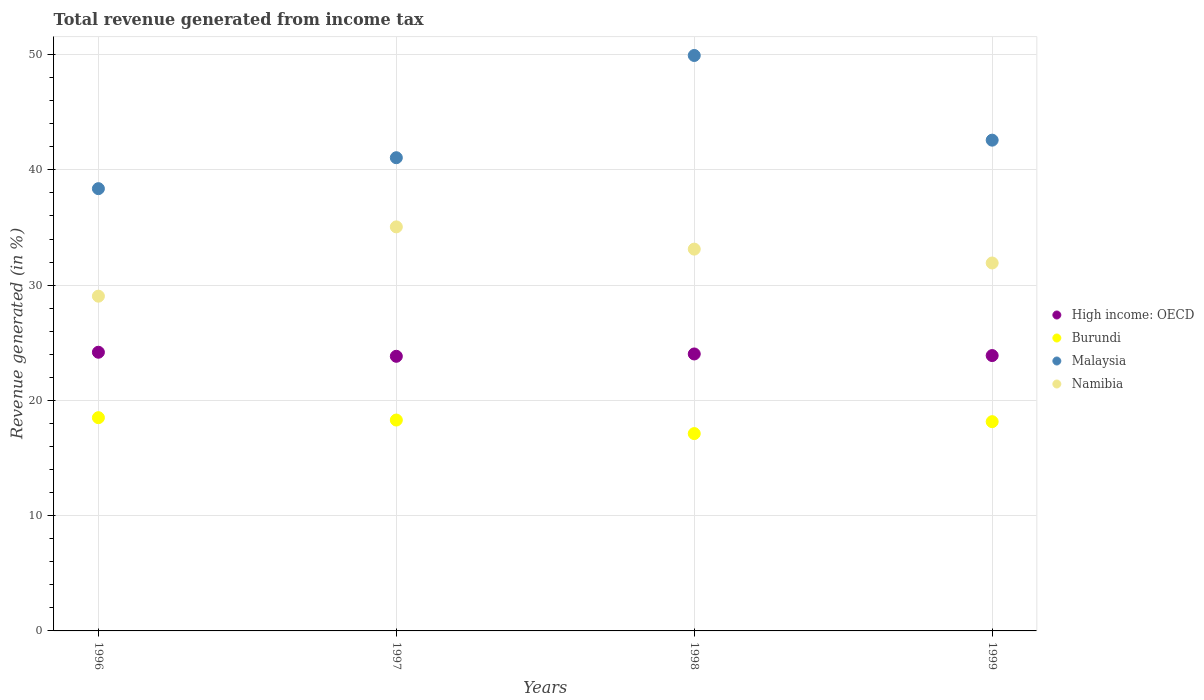Is the number of dotlines equal to the number of legend labels?
Give a very brief answer. Yes. What is the total revenue generated in Malaysia in 1997?
Keep it short and to the point. 41.06. Across all years, what is the maximum total revenue generated in High income: OECD?
Ensure brevity in your answer.  24.18. Across all years, what is the minimum total revenue generated in Malaysia?
Your answer should be very brief. 38.37. In which year was the total revenue generated in Burundi maximum?
Keep it short and to the point. 1996. What is the total total revenue generated in High income: OECD in the graph?
Keep it short and to the point. 95.92. What is the difference between the total revenue generated in Malaysia in 1996 and that in 1998?
Offer a very short reply. -11.55. What is the difference between the total revenue generated in Burundi in 1997 and the total revenue generated in Namibia in 1999?
Your answer should be compact. -13.63. What is the average total revenue generated in High income: OECD per year?
Give a very brief answer. 23.98. In the year 1997, what is the difference between the total revenue generated in High income: OECD and total revenue generated in Namibia?
Offer a very short reply. -11.23. What is the ratio of the total revenue generated in Namibia in 1996 to that in 1999?
Your answer should be compact. 0.91. What is the difference between the highest and the second highest total revenue generated in High income: OECD?
Make the answer very short. 0.15. What is the difference between the highest and the lowest total revenue generated in Burundi?
Make the answer very short. 1.38. In how many years, is the total revenue generated in Malaysia greater than the average total revenue generated in Malaysia taken over all years?
Give a very brief answer. 1. Is it the case that in every year, the sum of the total revenue generated in Burundi and total revenue generated in Malaysia  is greater than the total revenue generated in High income: OECD?
Offer a very short reply. Yes. Does the total revenue generated in High income: OECD monotonically increase over the years?
Keep it short and to the point. No. Is the total revenue generated in Namibia strictly greater than the total revenue generated in Malaysia over the years?
Give a very brief answer. No. Is the total revenue generated in Malaysia strictly less than the total revenue generated in Burundi over the years?
Ensure brevity in your answer.  No. How many years are there in the graph?
Make the answer very short. 4. Does the graph contain any zero values?
Provide a succinct answer. No. What is the title of the graph?
Your answer should be compact. Total revenue generated from income tax. What is the label or title of the Y-axis?
Keep it short and to the point. Revenue generated (in %). What is the Revenue generated (in %) in High income: OECD in 1996?
Keep it short and to the point. 24.18. What is the Revenue generated (in %) of Burundi in 1996?
Make the answer very short. 18.5. What is the Revenue generated (in %) in Malaysia in 1996?
Your answer should be very brief. 38.37. What is the Revenue generated (in %) of Namibia in 1996?
Keep it short and to the point. 29.04. What is the Revenue generated (in %) in High income: OECD in 1997?
Your response must be concise. 23.83. What is the Revenue generated (in %) in Burundi in 1997?
Your answer should be very brief. 18.3. What is the Revenue generated (in %) in Malaysia in 1997?
Offer a terse response. 41.06. What is the Revenue generated (in %) in Namibia in 1997?
Provide a short and direct response. 35.05. What is the Revenue generated (in %) in High income: OECD in 1998?
Ensure brevity in your answer.  24.03. What is the Revenue generated (in %) of Burundi in 1998?
Give a very brief answer. 17.12. What is the Revenue generated (in %) in Malaysia in 1998?
Provide a succinct answer. 49.93. What is the Revenue generated (in %) of Namibia in 1998?
Your answer should be very brief. 33.13. What is the Revenue generated (in %) in High income: OECD in 1999?
Ensure brevity in your answer.  23.89. What is the Revenue generated (in %) of Burundi in 1999?
Offer a very short reply. 18.15. What is the Revenue generated (in %) of Malaysia in 1999?
Provide a succinct answer. 42.58. What is the Revenue generated (in %) of Namibia in 1999?
Give a very brief answer. 31.92. Across all years, what is the maximum Revenue generated (in %) of High income: OECD?
Provide a succinct answer. 24.18. Across all years, what is the maximum Revenue generated (in %) in Burundi?
Give a very brief answer. 18.5. Across all years, what is the maximum Revenue generated (in %) in Malaysia?
Keep it short and to the point. 49.93. Across all years, what is the maximum Revenue generated (in %) of Namibia?
Provide a short and direct response. 35.05. Across all years, what is the minimum Revenue generated (in %) of High income: OECD?
Your answer should be compact. 23.83. Across all years, what is the minimum Revenue generated (in %) of Burundi?
Keep it short and to the point. 17.12. Across all years, what is the minimum Revenue generated (in %) in Malaysia?
Keep it short and to the point. 38.37. Across all years, what is the minimum Revenue generated (in %) of Namibia?
Ensure brevity in your answer.  29.04. What is the total Revenue generated (in %) of High income: OECD in the graph?
Your answer should be compact. 95.92. What is the total Revenue generated (in %) in Burundi in the graph?
Your answer should be compact. 72.07. What is the total Revenue generated (in %) of Malaysia in the graph?
Offer a terse response. 171.93. What is the total Revenue generated (in %) in Namibia in the graph?
Give a very brief answer. 129.15. What is the difference between the Revenue generated (in %) in High income: OECD in 1996 and that in 1997?
Your answer should be very brief. 0.35. What is the difference between the Revenue generated (in %) in Burundi in 1996 and that in 1997?
Make the answer very short. 0.21. What is the difference between the Revenue generated (in %) in Malaysia in 1996 and that in 1997?
Keep it short and to the point. -2.68. What is the difference between the Revenue generated (in %) in Namibia in 1996 and that in 1997?
Keep it short and to the point. -6.01. What is the difference between the Revenue generated (in %) in High income: OECD in 1996 and that in 1998?
Offer a terse response. 0.15. What is the difference between the Revenue generated (in %) in Burundi in 1996 and that in 1998?
Keep it short and to the point. 1.38. What is the difference between the Revenue generated (in %) in Malaysia in 1996 and that in 1998?
Offer a terse response. -11.55. What is the difference between the Revenue generated (in %) of Namibia in 1996 and that in 1998?
Your answer should be very brief. -4.08. What is the difference between the Revenue generated (in %) in High income: OECD in 1996 and that in 1999?
Your answer should be very brief. 0.29. What is the difference between the Revenue generated (in %) in Burundi in 1996 and that in 1999?
Provide a short and direct response. 0.35. What is the difference between the Revenue generated (in %) in Malaysia in 1996 and that in 1999?
Provide a succinct answer. -4.21. What is the difference between the Revenue generated (in %) in Namibia in 1996 and that in 1999?
Offer a very short reply. -2.88. What is the difference between the Revenue generated (in %) of High income: OECD in 1997 and that in 1998?
Provide a succinct answer. -0.2. What is the difference between the Revenue generated (in %) of Burundi in 1997 and that in 1998?
Ensure brevity in your answer.  1.18. What is the difference between the Revenue generated (in %) of Malaysia in 1997 and that in 1998?
Give a very brief answer. -8.87. What is the difference between the Revenue generated (in %) of Namibia in 1997 and that in 1998?
Provide a short and direct response. 1.93. What is the difference between the Revenue generated (in %) in High income: OECD in 1997 and that in 1999?
Provide a short and direct response. -0.06. What is the difference between the Revenue generated (in %) of Burundi in 1997 and that in 1999?
Your answer should be compact. 0.14. What is the difference between the Revenue generated (in %) in Malaysia in 1997 and that in 1999?
Provide a succinct answer. -1.52. What is the difference between the Revenue generated (in %) of Namibia in 1997 and that in 1999?
Offer a very short reply. 3.13. What is the difference between the Revenue generated (in %) in High income: OECD in 1998 and that in 1999?
Make the answer very short. 0.14. What is the difference between the Revenue generated (in %) in Burundi in 1998 and that in 1999?
Offer a terse response. -1.03. What is the difference between the Revenue generated (in %) of Malaysia in 1998 and that in 1999?
Your answer should be very brief. 7.35. What is the difference between the Revenue generated (in %) of Namibia in 1998 and that in 1999?
Ensure brevity in your answer.  1.2. What is the difference between the Revenue generated (in %) in High income: OECD in 1996 and the Revenue generated (in %) in Burundi in 1997?
Make the answer very short. 5.88. What is the difference between the Revenue generated (in %) in High income: OECD in 1996 and the Revenue generated (in %) in Malaysia in 1997?
Provide a succinct answer. -16.88. What is the difference between the Revenue generated (in %) of High income: OECD in 1996 and the Revenue generated (in %) of Namibia in 1997?
Make the answer very short. -10.88. What is the difference between the Revenue generated (in %) of Burundi in 1996 and the Revenue generated (in %) of Malaysia in 1997?
Your answer should be very brief. -22.55. What is the difference between the Revenue generated (in %) in Burundi in 1996 and the Revenue generated (in %) in Namibia in 1997?
Make the answer very short. -16.55. What is the difference between the Revenue generated (in %) in Malaysia in 1996 and the Revenue generated (in %) in Namibia in 1997?
Give a very brief answer. 3.32. What is the difference between the Revenue generated (in %) of High income: OECD in 1996 and the Revenue generated (in %) of Burundi in 1998?
Ensure brevity in your answer.  7.06. What is the difference between the Revenue generated (in %) in High income: OECD in 1996 and the Revenue generated (in %) in Malaysia in 1998?
Provide a short and direct response. -25.75. What is the difference between the Revenue generated (in %) of High income: OECD in 1996 and the Revenue generated (in %) of Namibia in 1998?
Ensure brevity in your answer.  -8.95. What is the difference between the Revenue generated (in %) of Burundi in 1996 and the Revenue generated (in %) of Malaysia in 1998?
Your response must be concise. -31.42. What is the difference between the Revenue generated (in %) in Burundi in 1996 and the Revenue generated (in %) in Namibia in 1998?
Give a very brief answer. -14.62. What is the difference between the Revenue generated (in %) of Malaysia in 1996 and the Revenue generated (in %) of Namibia in 1998?
Make the answer very short. 5.25. What is the difference between the Revenue generated (in %) in High income: OECD in 1996 and the Revenue generated (in %) in Burundi in 1999?
Offer a very short reply. 6.02. What is the difference between the Revenue generated (in %) of High income: OECD in 1996 and the Revenue generated (in %) of Malaysia in 1999?
Provide a short and direct response. -18.4. What is the difference between the Revenue generated (in %) of High income: OECD in 1996 and the Revenue generated (in %) of Namibia in 1999?
Your answer should be compact. -7.74. What is the difference between the Revenue generated (in %) in Burundi in 1996 and the Revenue generated (in %) in Malaysia in 1999?
Your response must be concise. -24.08. What is the difference between the Revenue generated (in %) of Burundi in 1996 and the Revenue generated (in %) of Namibia in 1999?
Your response must be concise. -13.42. What is the difference between the Revenue generated (in %) in Malaysia in 1996 and the Revenue generated (in %) in Namibia in 1999?
Offer a terse response. 6.45. What is the difference between the Revenue generated (in %) of High income: OECD in 1997 and the Revenue generated (in %) of Burundi in 1998?
Keep it short and to the point. 6.71. What is the difference between the Revenue generated (in %) of High income: OECD in 1997 and the Revenue generated (in %) of Malaysia in 1998?
Provide a succinct answer. -26.1. What is the difference between the Revenue generated (in %) of High income: OECD in 1997 and the Revenue generated (in %) of Namibia in 1998?
Your response must be concise. -9.3. What is the difference between the Revenue generated (in %) in Burundi in 1997 and the Revenue generated (in %) in Malaysia in 1998?
Ensure brevity in your answer.  -31.63. What is the difference between the Revenue generated (in %) of Burundi in 1997 and the Revenue generated (in %) of Namibia in 1998?
Your answer should be very brief. -14.83. What is the difference between the Revenue generated (in %) of Malaysia in 1997 and the Revenue generated (in %) of Namibia in 1998?
Offer a very short reply. 7.93. What is the difference between the Revenue generated (in %) in High income: OECD in 1997 and the Revenue generated (in %) in Burundi in 1999?
Provide a short and direct response. 5.67. What is the difference between the Revenue generated (in %) of High income: OECD in 1997 and the Revenue generated (in %) of Malaysia in 1999?
Ensure brevity in your answer.  -18.75. What is the difference between the Revenue generated (in %) of High income: OECD in 1997 and the Revenue generated (in %) of Namibia in 1999?
Your answer should be very brief. -8.1. What is the difference between the Revenue generated (in %) in Burundi in 1997 and the Revenue generated (in %) in Malaysia in 1999?
Your answer should be very brief. -24.28. What is the difference between the Revenue generated (in %) in Burundi in 1997 and the Revenue generated (in %) in Namibia in 1999?
Your answer should be compact. -13.63. What is the difference between the Revenue generated (in %) in Malaysia in 1997 and the Revenue generated (in %) in Namibia in 1999?
Provide a succinct answer. 9.13. What is the difference between the Revenue generated (in %) of High income: OECD in 1998 and the Revenue generated (in %) of Burundi in 1999?
Your answer should be very brief. 5.87. What is the difference between the Revenue generated (in %) in High income: OECD in 1998 and the Revenue generated (in %) in Malaysia in 1999?
Your response must be concise. -18.55. What is the difference between the Revenue generated (in %) of High income: OECD in 1998 and the Revenue generated (in %) of Namibia in 1999?
Ensure brevity in your answer.  -7.89. What is the difference between the Revenue generated (in %) of Burundi in 1998 and the Revenue generated (in %) of Malaysia in 1999?
Keep it short and to the point. -25.46. What is the difference between the Revenue generated (in %) of Burundi in 1998 and the Revenue generated (in %) of Namibia in 1999?
Your answer should be compact. -14.8. What is the difference between the Revenue generated (in %) of Malaysia in 1998 and the Revenue generated (in %) of Namibia in 1999?
Provide a short and direct response. 18. What is the average Revenue generated (in %) of High income: OECD per year?
Keep it short and to the point. 23.98. What is the average Revenue generated (in %) of Burundi per year?
Provide a succinct answer. 18.02. What is the average Revenue generated (in %) in Malaysia per year?
Keep it short and to the point. 42.98. What is the average Revenue generated (in %) in Namibia per year?
Provide a short and direct response. 32.29. In the year 1996, what is the difference between the Revenue generated (in %) of High income: OECD and Revenue generated (in %) of Burundi?
Ensure brevity in your answer.  5.68. In the year 1996, what is the difference between the Revenue generated (in %) of High income: OECD and Revenue generated (in %) of Malaysia?
Keep it short and to the point. -14.19. In the year 1996, what is the difference between the Revenue generated (in %) of High income: OECD and Revenue generated (in %) of Namibia?
Ensure brevity in your answer.  -4.86. In the year 1996, what is the difference between the Revenue generated (in %) of Burundi and Revenue generated (in %) of Malaysia?
Give a very brief answer. -19.87. In the year 1996, what is the difference between the Revenue generated (in %) of Burundi and Revenue generated (in %) of Namibia?
Ensure brevity in your answer.  -10.54. In the year 1996, what is the difference between the Revenue generated (in %) of Malaysia and Revenue generated (in %) of Namibia?
Keep it short and to the point. 9.33. In the year 1997, what is the difference between the Revenue generated (in %) of High income: OECD and Revenue generated (in %) of Burundi?
Your answer should be very brief. 5.53. In the year 1997, what is the difference between the Revenue generated (in %) in High income: OECD and Revenue generated (in %) in Malaysia?
Provide a succinct answer. -17.23. In the year 1997, what is the difference between the Revenue generated (in %) in High income: OECD and Revenue generated (in %) in Namibia?
Give a very brief answer. -11.23. In the year 1997, what is the difference between the Revenue generated (in %) of Burundi and Revenue generated (in %) of Malaysia?
Keep it short and to the point. -22.76. In the year 1997, what is the difference between the Revenue generated (in %) of Burundi and Revenue generated (in %) of Namibia?
Offer a very short reply. -16.76. In the year 1997, what is the difference between the Revenue generated (in %) in Malaysia and Revenue generated (in %) in Namibia?
Provide a short and direct response. 6. In the year 1998, what is the difference between the Revenue generated (in %) of High income: OECD and Revenue generated (in %) of Burundi?
Provide a succinct answer. 6.91. In the year 1998, what is the difference between the Revenue generated (in %) in High income: OECD and Revenue generated (in %) in Malaysia?
Your response must be concise. -25.9. In the year 1998, what is the difference between the Revenue generated (in %) of High income: OECD and Revenue generated (in %) of Namibia?
Make the answer very short. -9.1. In the year 1998, what is the difference between the Revenue generated (in %) of Burundi and Revenue generated (in %) of Malaysia?
Your response must be concise. -32.8. In the year 1998, what is the difference between the Revenue generated (in %) of Burundi and Revenue generated (in %) of Namibia?
Keep it short and to the point. -16. In the year 1998, what is the difference between the Revenue generated (in %) in Malaysia and Revenue generated (in %) in Namibia?
Your response must be concise. 16.8. In the year 1999, what is the difference between the Revenue generated (in %) of High income: OECD and Revenue generated (in %) of Burundi?
Provide a short and direct response. 5.73. In the year 1999, what is the difference between the Revenue generated (in %) in High income: OECD and Revenue generated (in %) in Malaysia?
Your answer should be compact. -18.69. In the year 1999, what is the difference between the Revenue generated (in %) of High income: OECD and Revenue generated (in %) of Namibia?
Keep it short and to the point. -8.03. In the year 1999, what is the difference between the Revenue generated (in %) in Burundi and Revenue generated (in %) in Malaysia?
Your response must be concise. -24.42. In the year 1999, what is the difference between the Revenue generated (in %) of Burundi and Revenue generated (in %) of Namibia?
Your response must be concise. -13.77. In the year 1999, what is the difference between the Revenue generated (in %) of Malaysia and Revenue generated (in %) of Namibia?
Provide a succinct answer. 10.66. What is the ratio of the Revenue generated (in %) in High income: OECD in 1996 to that in 1997?
Provide a succinct answer. 1.01. What is the ratio of the Revenue generated (in %) in Burundi in 1996 to that in 1997?
Offer a very short reply. 1.01. What is the ratio of the Revenue generated (in %) of Malaysia in 1996 to that in 1997?
Your response must be concise. 0.93. What is the ratio of the Revenue generated (in %) of Namibia in 1996 to that in 1997?
Your answer should be very brief. 0.83. What is the ratio of the Revenue generated (in %) in High income: OECD in 1996 to that in 1998?
Keep it short and to the point. 1.01. What is the ratio of the Revenue generated (in %) of Burundi in 1996 to that in 1998?
Your answer should be compact. 1.08. What is the ratio of the Revenue generated (in %) of Malaysia in 1996 to that in 1998?
Give a very brief answer. 0.77. What is the ratio of the Revenue generated (in %) in Namibia in 1996 to that in 1998?
Your response must be concise. 0.88. What is the ratio of the Revenue generated (in %) in High income: OECD in 1996 to that in 1999?
Make the answer very short. 1.01. What is the ratio of the Revenue generated (in %) in Burundi in 1996 to that in 1999?
Your answer should be compact. 1.02. What is the ratio of the Revenue generated (in %) of Malaysia in 1996 to that in 1999?
Keep it short and to the point. 0.9. What is the ratio of the Revenue generated (in %) of Namibia in 1996 to that in 1999?
Give a very brief answer. 0.91. What is the ratio of the Revenue generated (in %) in High income: OECD in 1997 to that in 1998?
Offer a very short reply. 0.99. What is the ratio of the Revenue generated (in %) in Burundi in 1997 to that in 1998?
Your response must be concise. 1.07. What is the ratio of the Revenue generated (in %) of Malaysia in 1997 to that in 1998?
Offer a very short reply. 0.82. What is the ratio of the Revenue generated (in %) of Namibia in 1997 to that in 1998?
Your response must be concise. 1.06. What is the ratio of the Revenue generated (in %) of High income: OECD in 1997 to that in 1999?
Provide a short and direct response. 1. What is the ratio of the Revenue generated (in %) in Burundi in 1997 to that in 1999?
Ensure brevity in your answer.  1.01. What is the ratio of the Revenue generated (in %) in Malaysia in 1997 to that in 1999?
Give a very brief answer. 0.96. What is the ratio of the Revenue generated (in %) in Namibia in 1997 to that in 1999?
Your answer should be very brief. 1.1. What is the ratio of the Revenue generated (in %) of Burundi in 1998 to that in 1999?
Your answer should be very brief. 0.94. What is the ratio of the Revenue generated (in %) in Malaysia in 1998 to that in 1999?
Your answer should be compact. 1.17. What is the ratio of the Revenue generated (in %) in Namibia in 1998 to that in 1999?
Offer a terse response. 1.04. What is the difference between the highest and the second highest Revenue generated (in %) in High income: OECD?
Keep it short and to the point. 0.15. What is the difference between the highest and the second highest Revenue generated (in %) of Burundi?
Offer a terse response. 0.21. What is the difference between the highest and the second highest Revenue generated (in %) in Malaysia?
Your answer should be compact. 7.35. What is the difference between the highest and the second highest Revenue generated (in %) of Namibia?
Offer a terse response. 1.93. What is the difference between the highest and the lowest Revenue generated (in %) in High income: OECD?
Provide a succinct answer. 0.35. What is the difference between the highest and the lowest Revenue generated (in %) of Burundi?
Your answer should be very brief. 1.38. What is the difference between the highest and the lowest Revenue generated (in %) in Malaysia?
Offer a very short reply. 11.55. What is the difference between the highest and the lowest Revenue generated (in %) of Namibia?
Your response must be concise. 6.01. 